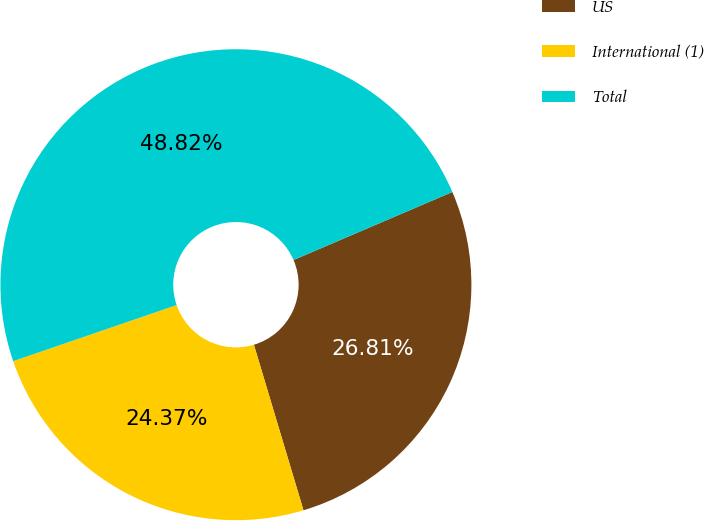Convert chart to OTSL. <chart><loc_0><loc_0><loc_500><loc_500><pie_chart><fcel>US<fcel>International (1)<fcel>Total<nl><fcel>26.81%<fcel>24.37%<fcel>48.82%<nl></chart> 